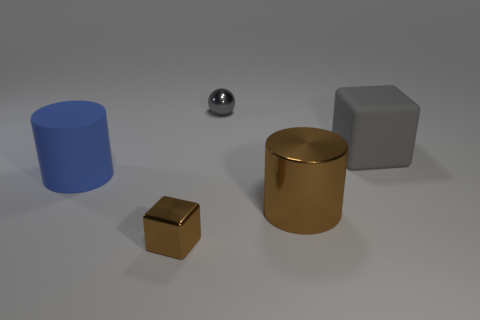Add 4 gray blocks. How many objects exist? 9 Subtract all spheres. How many objects are left? 4 Add 4 small blocks. How many small blocks are left? 5 Add 2 big yellow things. How many big yellow things exist? 2 Subtract 0 yellow cubes. How many objects are left? 5 Subtract all blocks. Subtract all gray metallic balls. How many objects are left? 2 